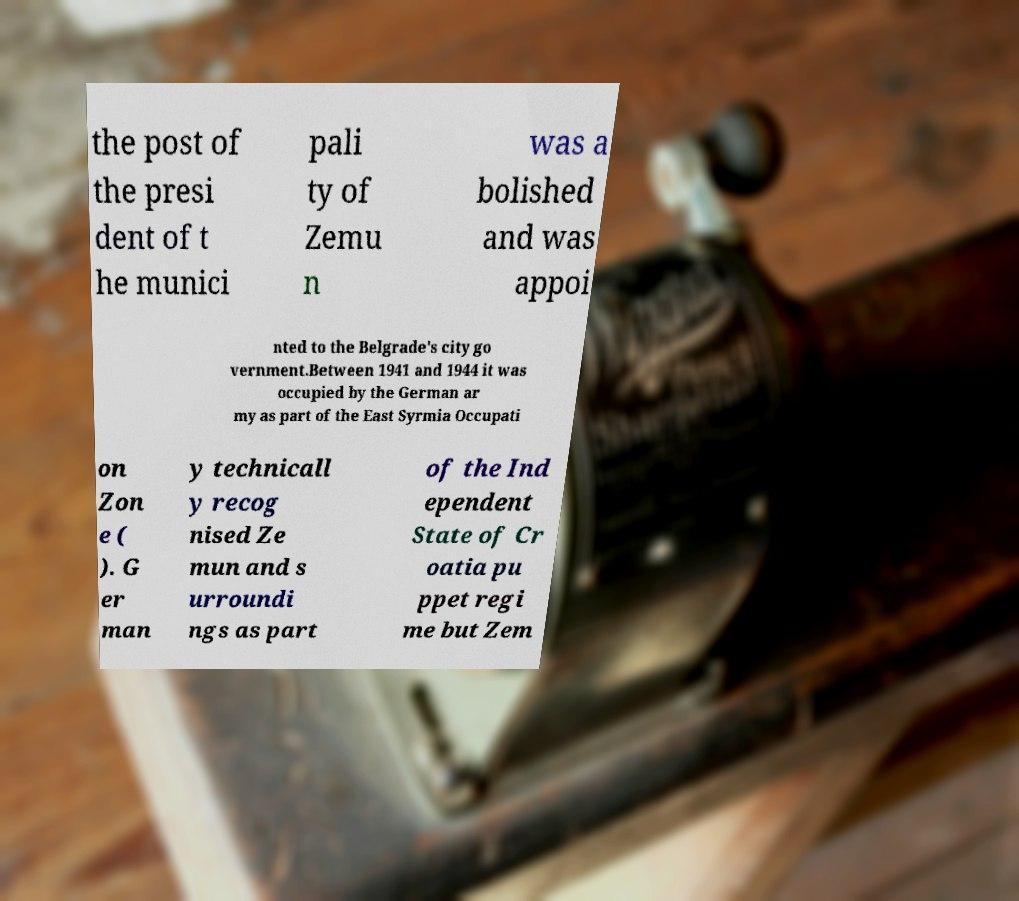Can you read and provide the text displayed in the image?This photo seems to have some interesting text. Can you extract and type it out for me? the post of the presi dent of t he munici pali ty of Zemu n was a bolished and was appoi nted to the Belgrade's city go vernment.Between 1941 and 1944 it was occupied by the German ar my as part of the East Syrmia Occupati on Zon e ( ). G er man y technicall y recog nised Ze mun and s urroundi ngs as part of the Ind ependent State of Cr oatia pu ppet regi me but Zem 